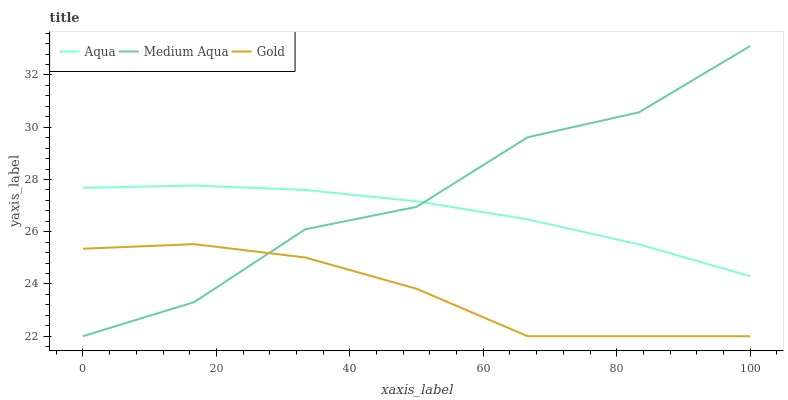Does Aqua have the minimum area under the curve?
Answer yes or no. No. Does Aqua have the maximum area under the curve?
Answer yes or no. No. Is Gold the smoothest?
Answer yes or no. No. Is Gold the roughest?
Answer yes or no. No. Does Aqua have the lowest value?
Answer yes or no. No. Does Aqua have the highest value?
Answer yes or no. No. Is Gold less than Aqua?
Answer yes or no. Yes. Is Aqua greater than Gold?
Answer yes or no. Yes. Does Gold intersect Aqua?
Answer yes or no. No. 